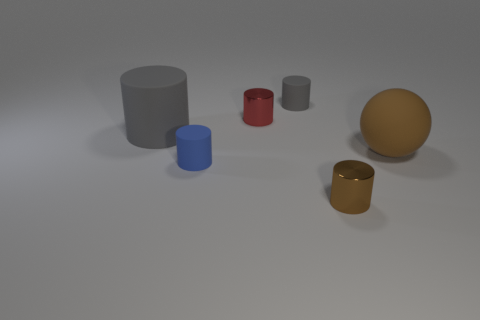Subtract all brown cylinders. How many cylinders are left? 4 Subtract all small brown metallic cylinders. How many cylinders are left? 4 Add 2 large brown objects. How many objects exist? 8 Subtract all gray spheres. Subtract all purple cylinders. How many spheres are left? 1 Subtract all balls. How many objects are left? 5 Add 6 blue rubber things. How many blue rubber things exist? 7 Subtract 0 yellow spheres. How many objects are left? 6 Subtract all small blue rubber cylinders. Subtract all brown matte objects. How many objects are left? 4 Add 3 large rubber objects. How many large rubber objects are left? 5 